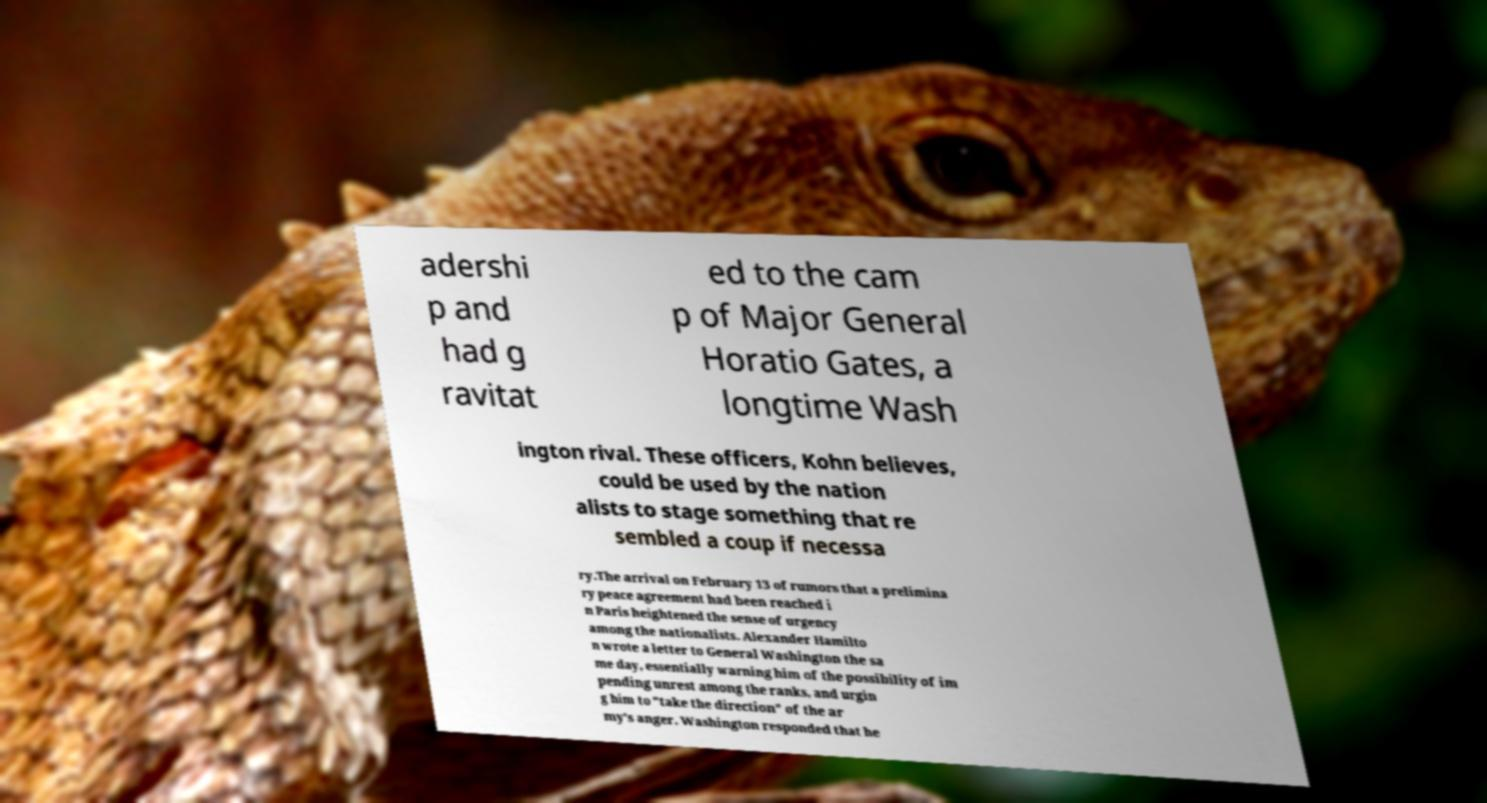I need the written content from this picture converted into text. Can you do that? adershi p and had g ravitat ed to the cam p of Major General Horatio Gates, a longtime Wash ington rival. These officers, Kohn believes, could be used by the nation alists to stage something that re sembled a coup if necessa ry.The arrival on February 13 of rumors that a prelimina ry peace agreement had been reached i n Paris heightened the sense of urgency among the nationalists. Alexander Hamilto n wrote a letter to General Washington the sa me day, essentially warning him of the possibility of im pending unrest among the ranks, and urgin g him to "take the direction" of the ar my's anger. Washington responded that he 